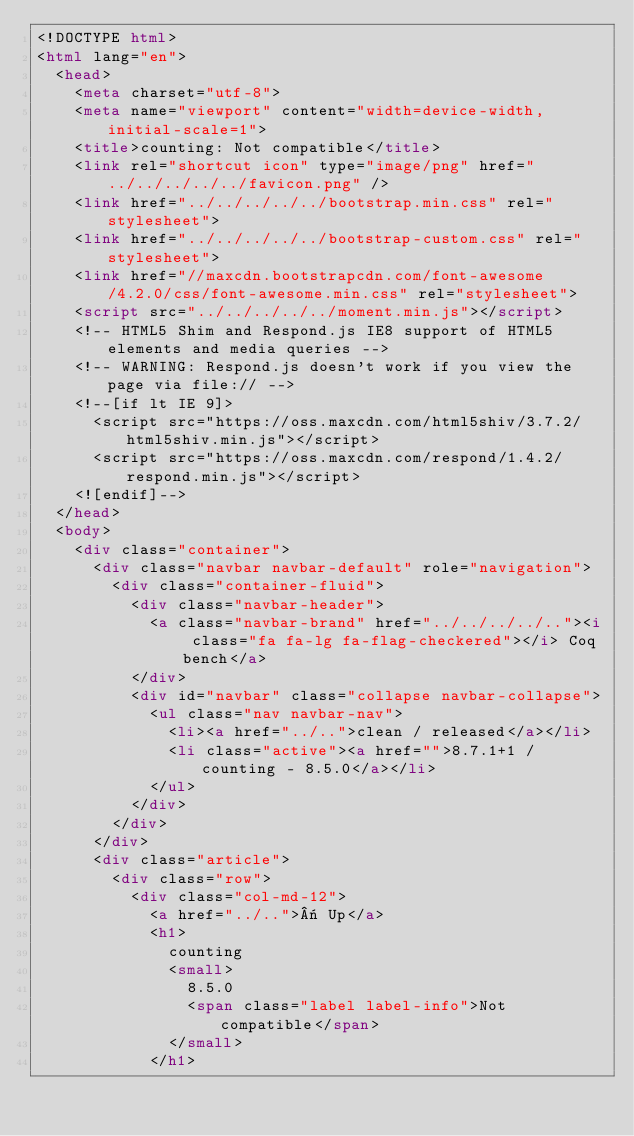<code> <loc_0><loc_0><loc_500><loc_500><_HTML_><!DOCTYPE html>
<html lang="en">
  <head>
    <meta charset="utf-8">
    <meta name="viewport" content="width=device-width, initial-scale=1">
    <title>counting: Not compatible</title>
    <link rel="shortcut icon" type="image/png" href="../../../../../favicon.png" />
    <link href="../../../../../bootstrap.min.css" rel="stylesheet">
    <link href="../../../../../bootstrap-custom.css" rel="stylesheet">
    <link href="//maxcdn.bootstrapcdn.com/font-awesome/4.2.0/css/font-awesome.min.css" rel="stylesheet">
    <script src="../../../../../moment.min.js"></script>
    <!-- HTML5 Shim and Respond.js IE8 support of HTML5 elements and media queries -->
    <!-- WARNING: Respond.js doesn't work if you view the page via file:// -->
    <!--[if lt IE 9]>
      <script src="https://oss.maxcdn.com/html5shiv/3.7.2/html5shiv.min.js"></script>
      <script src="https://oss.maxcdn.com/respond/1.4.2/respond.min.js"></script>
    <![endif]-->
  </head>
  <body>
    <div class="container">
      <div class="navbar navbar-default" role="navigation">
        <div class="container-fluid">
          <div class="navbar-header">
            <a class="navbar-brand" href="../../../../.."><i class="fa fa-lg fa-flag-checkered"></i> Coq bench</a>
          </div>
          <div id="navbar" class="collapse navbar-collapse">
            <ul class="nav navbar-nav">
              <li><a href="../..">clean / released</a></li>
              <li class="active"><a href="">8.7.1+1 / counting - 8.5.0</a></li>
            </ul>
          </div>
        </div>
      </div>
      <div class="article">
        <div class="row">
          <div class="col-md-12">
            <a href="../..">« Up</a>
            <h1>
              counting
              <small>
                8.5.0
                <span class="label label-info">Not compatible</span>
              </small>
            </h1></code> 